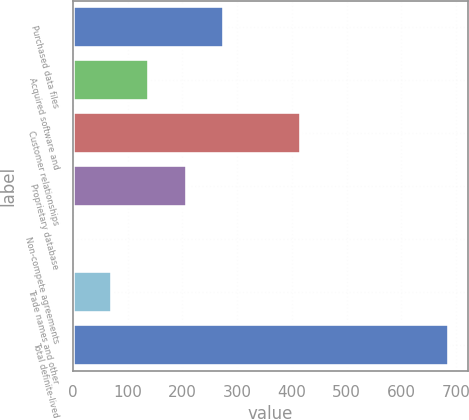Convert chart to OTSL. <chart><loc_0><loc_0><loc_500><loc_500><bar_chart><fcel>Purchased data files<fcel>Acquired software and<fcel>Customer relationships<fcel>Proprietary database<fcel>Non-compete agreements<fcel>Trade names and other<fcel>Total definite-lived<nl><fcel>276.48<fcel>139.64<fcel>417.2<fcel>208.06<fcel>2.8<fcel>71.22<fcel>687<nl></chart> 